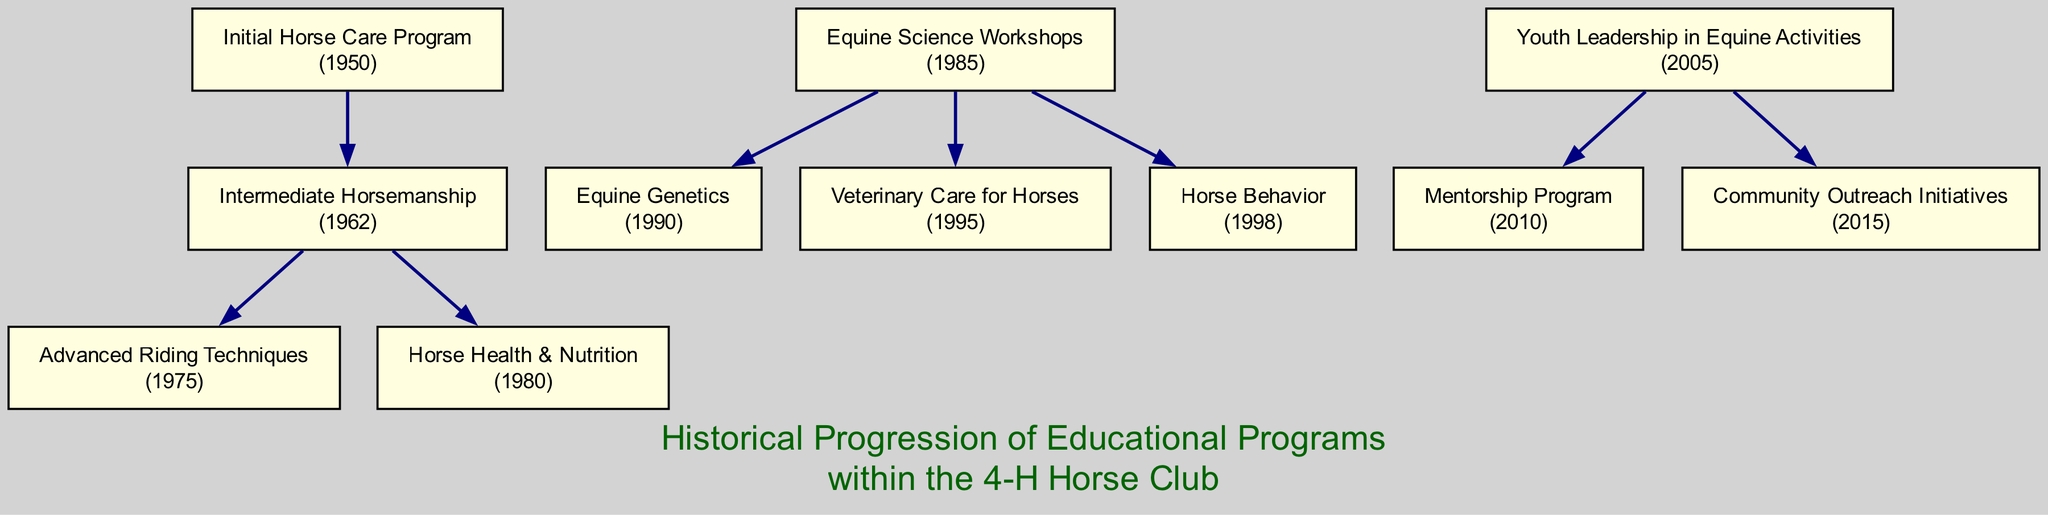What was the first educational program introduced in the club? The diagram shows that the first educational program initiated in the club was the "Initial Horse Care Program," which started in 1950.
Answer: Initial Horse Care Program How many descendants does the "Equine Science Workshops" program have? By examining the diagram, we can see that the "Equine Science Workshops" has three direct descendants: "Equine Genetics," "Veterinary Care for Horses," and "Horse Behavior." Therefore, it has a total of three descendants.
Answer: 3 What year did the "Community Outreach Initiatives" program start? The diagram indicates that the "Community Outreach Initiatives" program, which is a descendant of "Youth Leadership in Equine Activities," started in 2015.
Answer: 2015 Which educational program began immediately after the "Intermediate Horsemanship"? Looking at the succession of educational programs, the "Advanced Riding Techniques" and "Horse Health & Nutrition" are listed as descendants of "Intermediate Horsemanship," with "Advanced Riding Techniques" starting in 1975, following shortly after.
Answer: Advanced Riding Techniques How many total educational programs have been introduced from 1950 to 2023? By counting the main programs shown in the diagram, there are a total of five educational programs: "Initial Horse Care Program," "Equine Science Workshops," and "Youth Leadership in Equine Activities," along with all their descendants. Therefore, the total sums up to eight educational programs.
Answer: 8 Which program's start year is closest to 2000? By checking the years of each program, "Horse Behavior" started in 1998, which is the closest to 2000 among all the listed programs in the diagram.
Answer: Horse Behavior What is the last educational program mentioned in the tree? Following the tree structure, the last program that appears is the "Community Outreach Initiatives," which is a descendant of "Youth Leadership in Equine Activities."
Answer: Community Outreach Initiatives Which program has the most recent start year? Among all the educational programs listed, "Community Outreach Initiatives," which started in 2015, is the most recent program according to the information depicted in the diagram.
Answer: Community Outreach Initiatives 